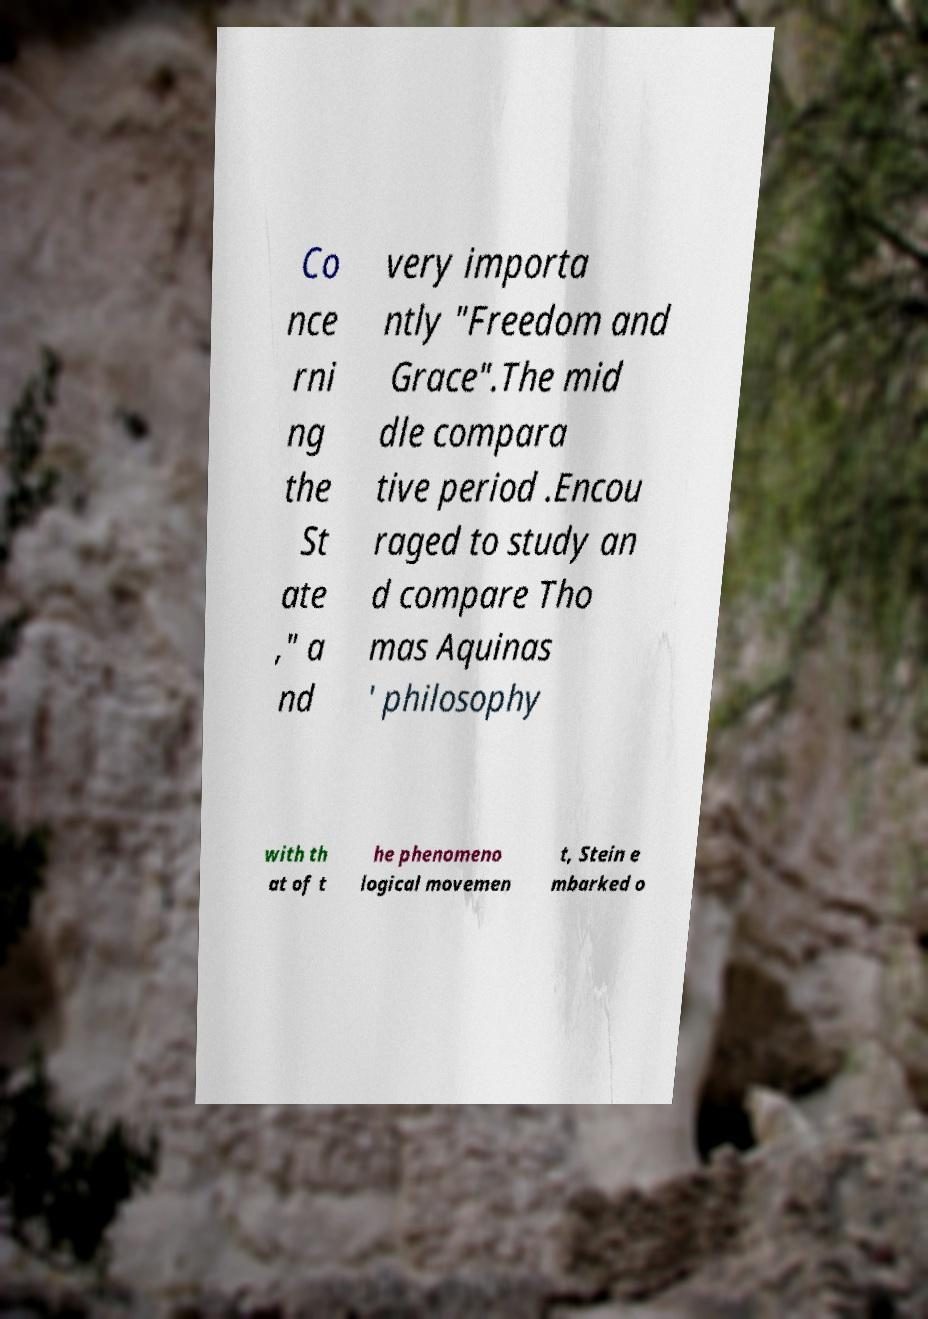I need the written content from this picture converted into text. Can you do that? Co nce rni ng the St ate ," a nd very importa ntly "Freedom and Grace".The mid dle compara tive period .Encou raged to study an d compare Tho mas Aquinas ' philosophy with th at of t he phenomeno logical movemen t, Stein e mbarked o 